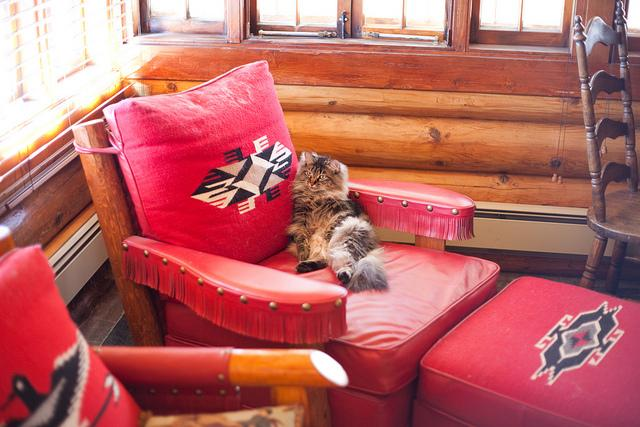What kind of walls are in this house? Please explain your reasoning. log. The walls look like a cabin wall. 